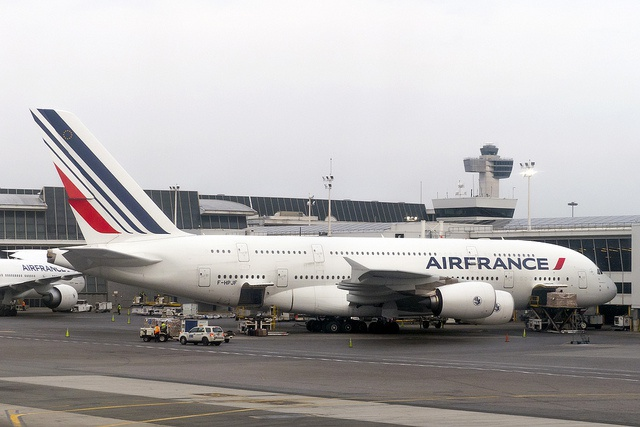Describe the objects in this image and their specific colors. I can see airplane in white, lightgray, gray, darkgray, and black tones, airplane in white, black, gray, and darkgray tones, car in white, black, darkgray, and gray tones, truck in white, gray, black, and darkgray tones, and people in white, black, red, orange, and salmon tones in this image. 